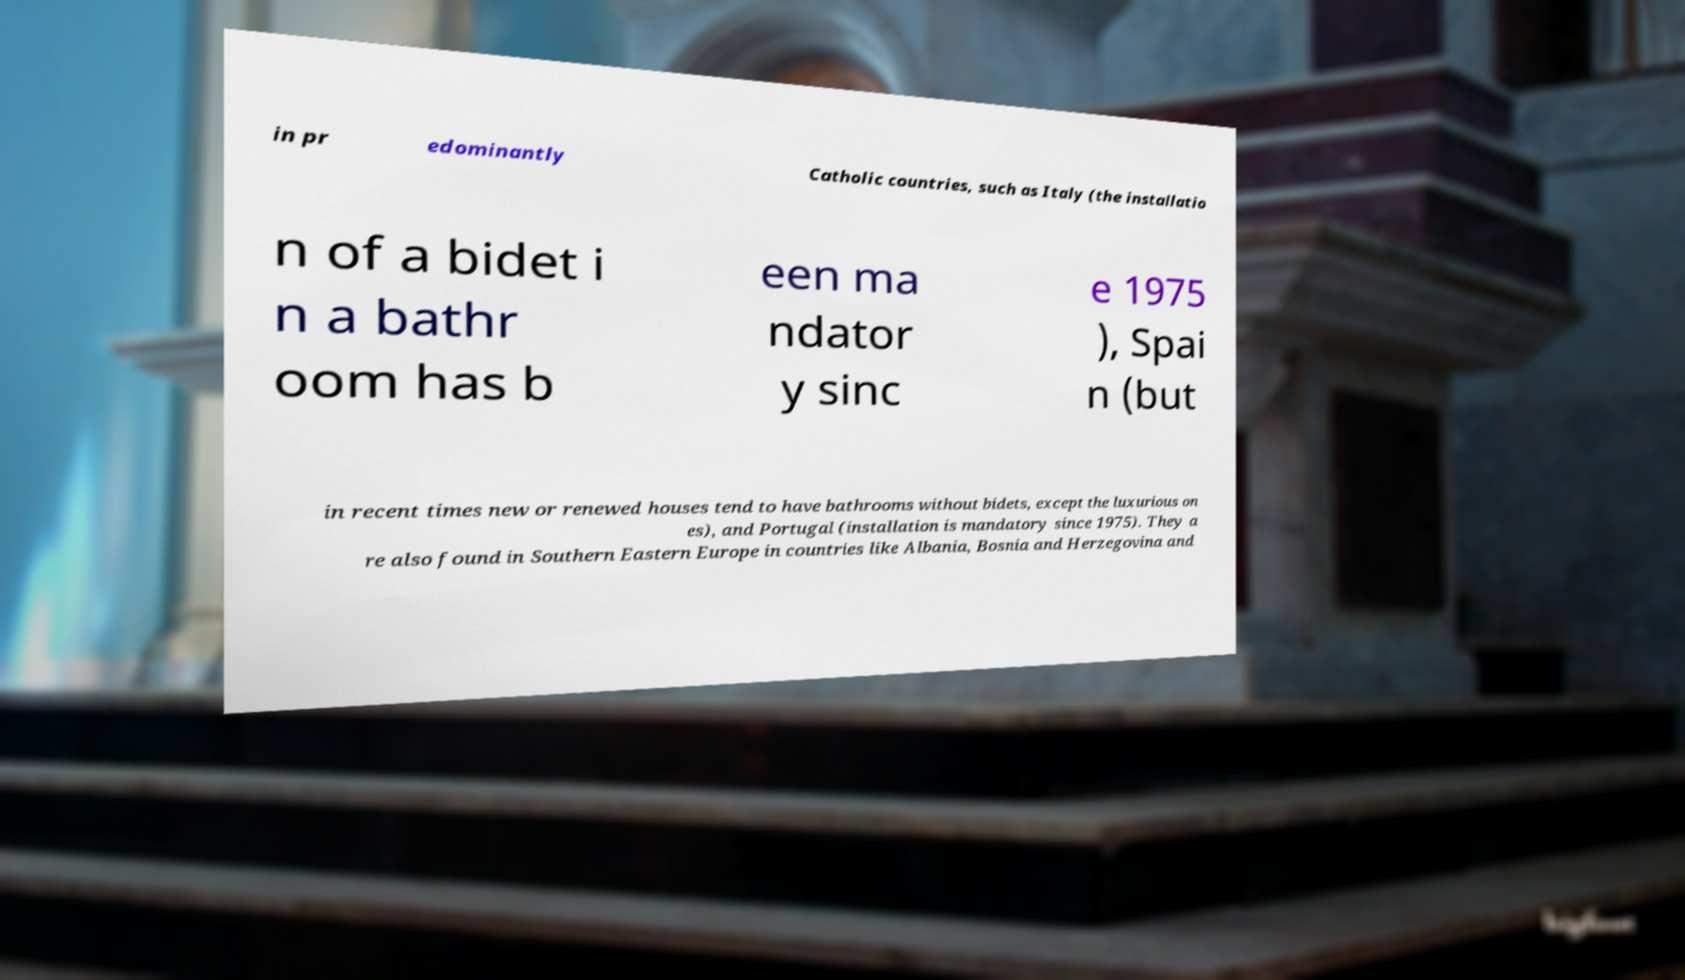Can you accurately transcribe the text from the provided image for me? in pr edominantly Catholic countries, such as Italy (the installatio n of a bidet i n a bathr oom has b een ma ndator y sinc e 1975 ), Spai n (but in recent times new or renewed houses tend to have bathrooms without bidets, except the luxurious on es), and Portugal (installation is mandatory since 1975). They a re also found in Southern Eastern Europe in countries like Albania, Bosnia and Herzegovina and 